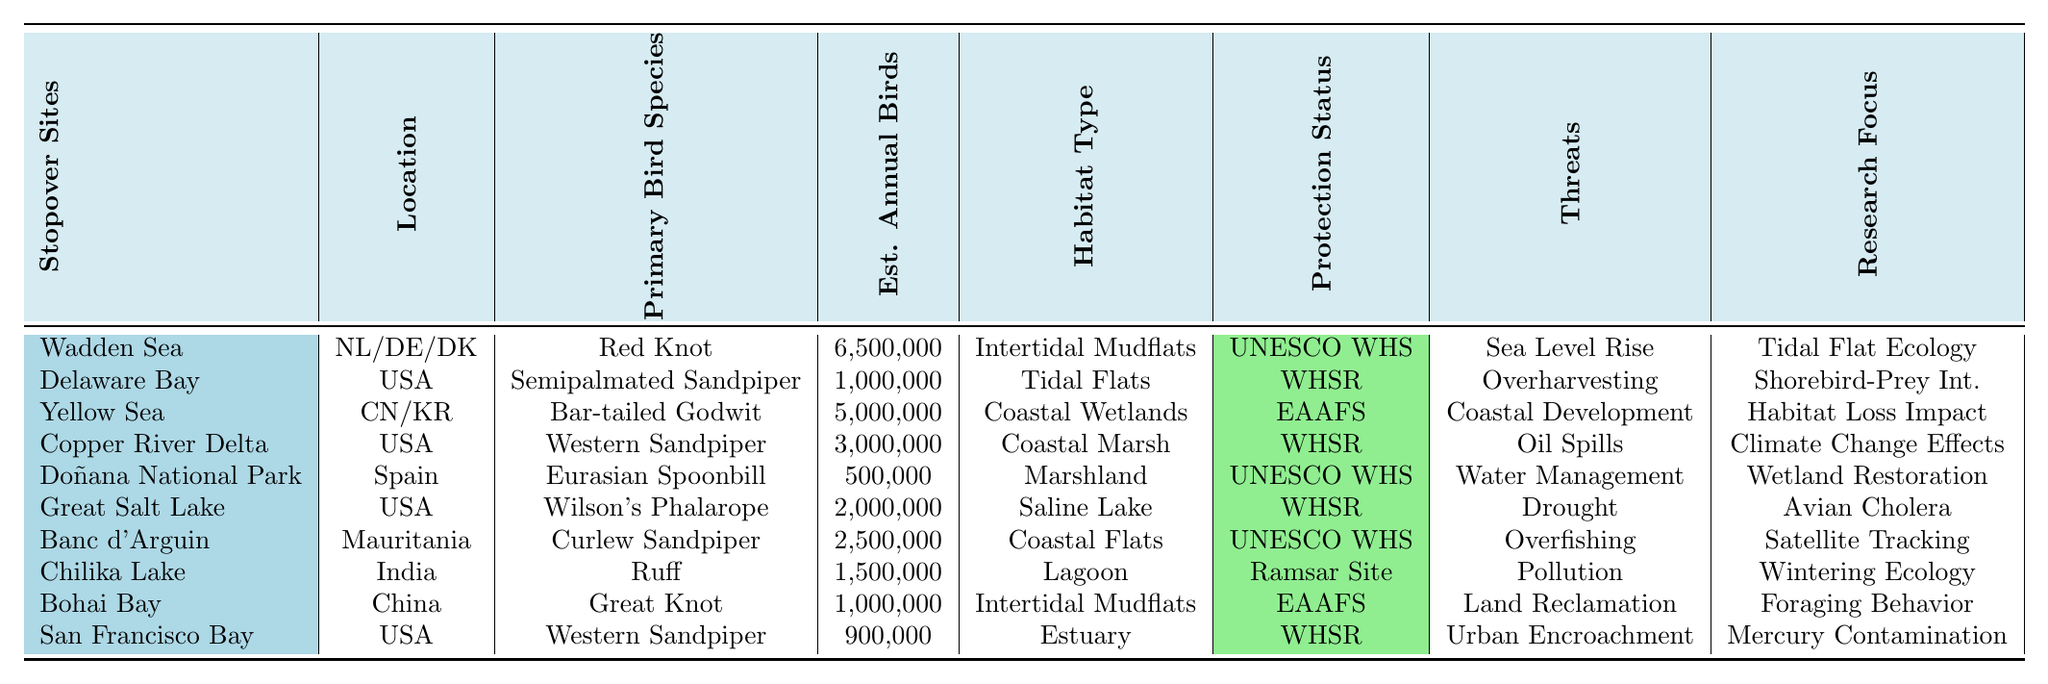What is the primary bird species found at the Wadden Sea? The table indicates that the primary bird species found at the Wadden Sea is the Red Knot.
Answer: Red Knot Which stopover site has the highest estimated annual birds? According to the table, the Wadden Sea has the highest estimated annual birds, with 6,500,000.
Answer: 6,500,000 How many stopover sites are located in the USA? By counting the entries under the "Location" column, there are 5 stopover sites listed as being in the USA.
Answer: 5 What habitat type is associated with the Great Salt Lake? The table specifies that the habitat type for the Great Salt Lake is a Saline Lake.
Answer: Saline Lake Is the Doñana National Park listed as a UNESCO World Heritage Site? The table shows that the Doñana National Park is marked as a UNESCO World Heritage Site.
Answer: Yes What is the total estimated annual birds from the Delaware Bay and the San Francisco Bay? The estimated annual birds for Delaware Bay is 1,000,000, and for San Francisco Bay is 900,000; thus, their total is 1,000,000 + 900,000 = 1,900,000.
Answer: 1,900,000 Which stopover site is threatened by overharvesting? The table indicates that Delaware Bay is threatened by overharvesting of Horseshoe Crabs.
Answer: Delaware Bay What is the average estimated annual birds across all stopover sites? To find the average, sum all estimated annual birds (6,500,000 + 1,000,000 + 5,000,000 + 3,000,000 + 500,000 + 2,000,000 + 2,500,000 + 1,500,000 + 1,000,000 + 900,000 = 24,900,000) and divide by the number of sites (10), which equals 24,900,000 / 10 = 2,490,000.
Answer: 2,490,000 Which site has the research focus on "Climate Change Effects"? The table shows that the Copper River Delta has the research focus on "Climate Change Effects".
Answer: Copper River Delta Are there more UNESCO World Heritage Sites or Ramsar Sites indicated in the table? The table lists 4 UNESCO World Heritage Sites (Wadden Sea, Doñana National Park, Banc d'Arguin) and 1 Ramsar Site (Chilika Lake), so there are more UNESCO World Heritage Sites.
Answer: More UNESCO World Heritage Sites 